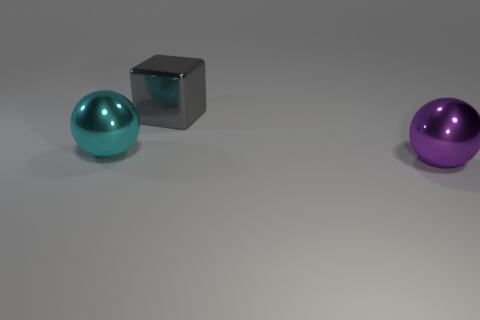Add 1 purple spheres. How many objects exist? 4 Subtract all blocks. How many objects are left? 2 Subtract 2 spheres. How many spheres are left? 0 Subtract all yellow spheres. Subtract all yellow cylinders. How many spheres are left? 2 Subtract all purple cylinders. How many cyan balls are left? 1 Subtract all gray cubes. Subtract all large purple metallic balls. How many objects are left? 1 Add 2 cyan spheres. How many cyan spheres are left? 3 Add 1 large cyan things. How many large cyan things exist? 2 Subtract 0 blue balls. How many objects are left? 3 